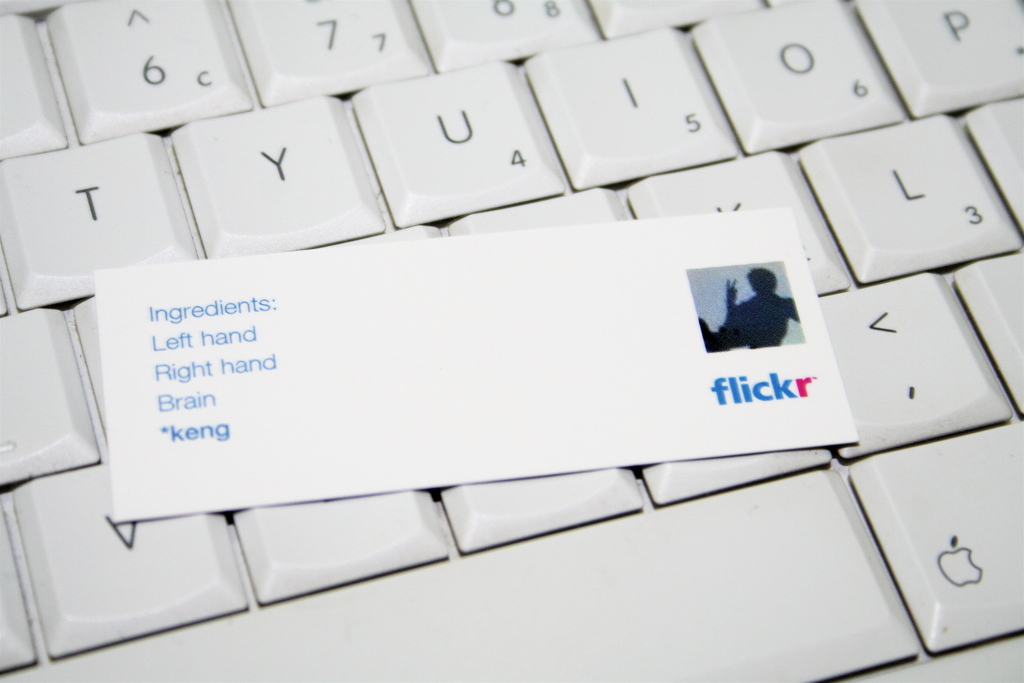Explain the visual content of the image in great detail. The image captures a moment of creativity, featuring a white keyboard serving as the backdrop for a small white card. The card, intriguingly, lists "Left hand", "Right hand", and "Brain" as ingredients, suggesting a metaphorical recipe for creation or work. Adding a personal touch, the word "keng" is inscribed in black text on the card. A small blue flickr logo is also present, hinting at a connection to the photo-sharing platform. The overall scene implies a workspace where ideas are transformed into reality, powered by the hands and mind of the creator. 